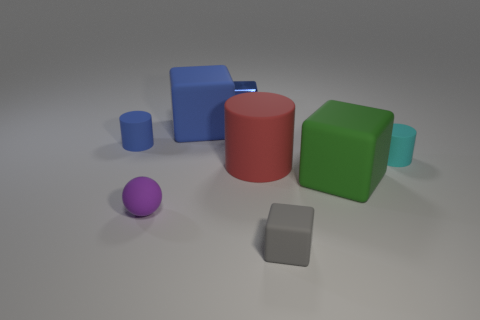There is a small cylinder that is right of the green cube; what number of small blue cylinders are in front of it?
Make the answer very short. 0. There is a matte block that is behind the green matte block; is its color the same as the small block that is on the left side of the large red rubber object?
Provide a succinct answer. Yes. What material is the blue cylinder that is the same size as the purple rubber sphere?
Offer a very short reply. Rubber. What shape is the blue matte object that is in front of the big object behind the tiny cylinder that is to the right of the big green block?
Offer a very short reply. Cylinder. What is the shape of the blue rubber thing that is the same size as the blue metallic cube?
Your response must be concise. Cylinder. How many large blocks are left of the large rubber block on the right side of the blue block that is left of the small blue cube?
Give a very brief answer. 1. Is the number of small cyan objects that are to the left of the green matte object greater than the number of blocks that are in front of the large blue rubber block?
Provide a short and direct response. No. How many tiny gray rubber things have the same shape as the big green matte object?
Make the answer very short. 1. What number of things are tiny objects to the left of the cyan cylinder or small things to the left of the small purple matte ball?
Give a very brief answer. 4. The large cube behind the small cylinder that is left of the matte object that is on the right side of the green matte thing is made of what material?
Offer a very short reply. Rubber. 